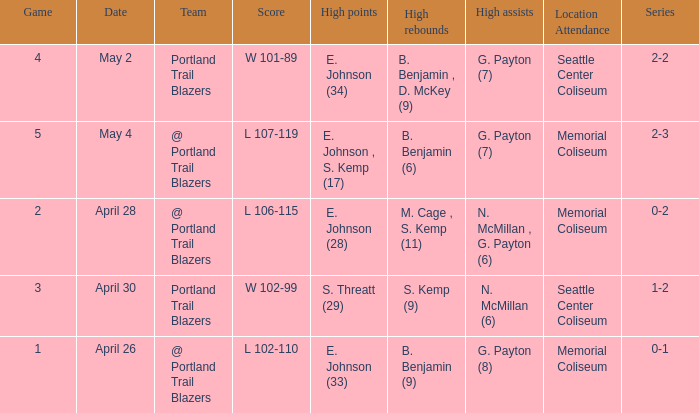With a 0-2 series, what is the high points? E. Johnson (28). 